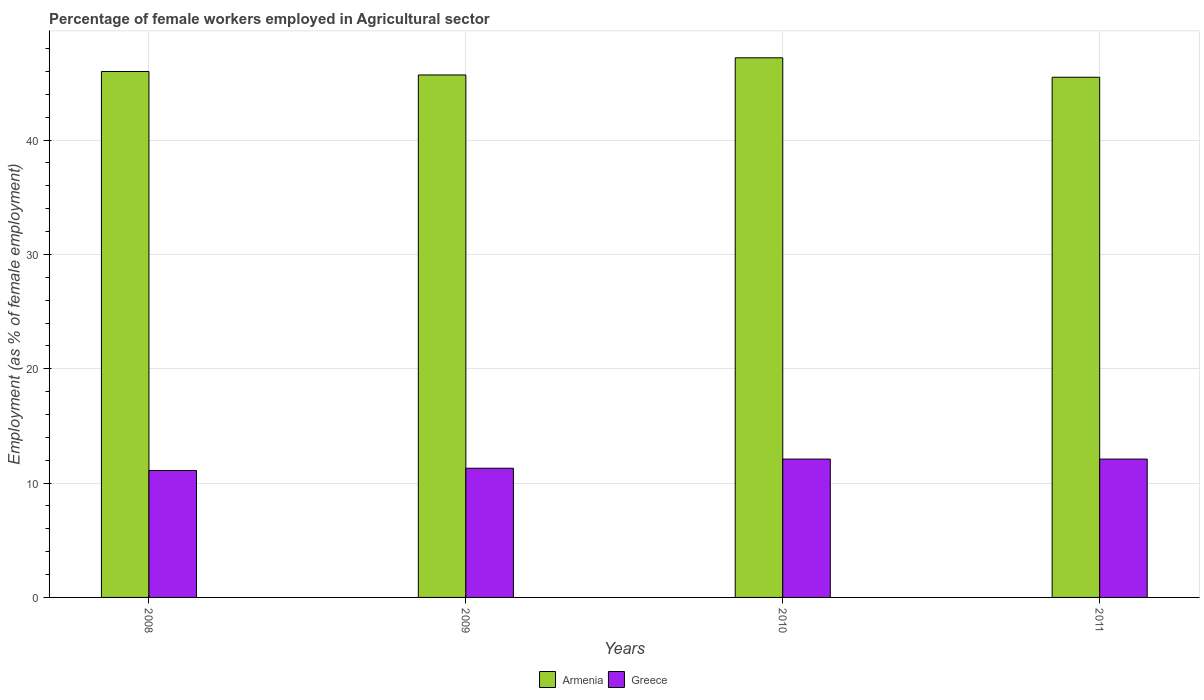How many different coloured bars are there?
Ensure brevity in your answer.  2. Are the number of bars per tick equal to the number of legend labels?
Give a very brief answer. Yes. In how many cases, is the number of bars for a given year not equal to the number of legend labels?
Make the answer very short. 0. What is the percentage of females employed in Agricultural sector in Greece in 2009?
Give a very brief answer. 11.3. Across all years, what is the maximum percentage of females employed in Agricultural sector in Armenia?
Give a very brief answer. 47.2. Across all years, what is the minimum percentage of females employed in Agricultural sector in Greece?
Offer a very short reply. 11.1. What is the total percentage of females employed in Agricultural sector in Armenia in the graph?
Your answer should be very brief. 184.4. What is the difference between the percentage of females employed in Agricultural sector in Armenia in 2008 and that in 2009?
Offer a terse response. 0.3. What is the difference between the percentage of females employed in Agricultural sector in Armenia in 2010 and the percentage of females employed in Agricultural sector in Greece in 2009?
Keep it short and to the point. 35.9. What is the average percentage of females employed in Agricultural sector in Greece per year?
Your answer should be very brief. 11.65. In the year 2010, what is the difference between the percentage of females employed in Agricultural sector in Armenia and percentage of females employed in Agricultural sector in Greece?
Make the answer very short. 35.1. What is the ratio of the percentage of females employed in Agricultural sector in Greece in 2008 to that in 2010?
Provide a short and direct response. 0.92. Is the difference between the percentage of females employed in Agricultural sector in Armenia in 2010 and 2011 greater than the difference between the percentage of females employed in Agricultural sector in Greece in 2010 and 2011?
Your answer should be very brief. Yes. What is the difference between the highest and the second highest percentage of females employed in Agricultural sector in Greece?
Your answer should be very brief. 0. What is the difference between the highest and the lowest percentage of females employed in Agricultural sector in Greece?
Your answer should be very brief. 1. What does the 2nd bar from the left in 2011 represents?
Offer a very short reply. Greece. How many years are there in the graph?
Make the answer very short. 4. What is the difference between two consecutive major ticks on the Y-axis?
Your response must be concise. 10. Are the values on the major ticks of Y-axis written in scientific E-notation?
Offer a very short reply. No. Does the graph contain grids?
Keep it short and to the point. Yes. How are the legend labels stacked?
Offer a very short reply. Horizontal. What is the title of the graph?
Make the answer very short. Percentage of female workers employed in Agricultural sector. Does "Mali" appear as one of the legend labels in the graph?
Offer a terse response. No. What is the label or title of the Y-axis?
Provide a short and direct response. Employment (as % of female employment). What is the Employment (as % of female employment) of Armenia in 2008?
Provide a short and direct response. 46. What is the Employment (as % of female employment) in Greece in 2008?
Offer a very short reply. 11.1. What is the Employment (as % of female employment) in Armenia in 2009?
Keep it short and to the point. 45.7. What is the Employment (as % of female employment) in Greece in 2009?
Your answer should be compact. 11.3. What is the Employment (as % of female employment) of Armenia in 2010?
Ensure brevity in your answer.  47.2. What is the Employment (as % of female employment) in Greece in 2010?
Give a very brief answer. 12.1. What is the Employment (as % of female employment) in Armenia in 2011?
Make the answer very short. 45.5. What is the Employment (as % of female employment) in Greece in 2011?
Keep it short and to the point. 12.1. Across all years, what is the maximum Employment (as % of female employment) of Armenia?
Provide a short and direct response. 47.2. Across all years, what is the maximum Employment (as % of female employment) of Greece?
Ensure brevity in your answer.  12.1. Across all years, what is the minimum Employment (as % of female employment) in Armenia?
Your answer should be compact. 45.5. Across all years, what is the minimum Employment (as % of female employment) of Greece?
Make the answer very short. 11.1. What is the total Employment (as % of female employment) in Armenia in the graph?
Provide a short and direct response. 184.4. What is the total Employment (as % of female employment) in Greece in the graph?
Your answer should be compact. 46.6. What is the difference between the Employment (as % of female employment) of Armenia in 2008 and that in 2009?
Ensure brevity in your answer.  0.3. What is the difference between the Employment (as % of female employment) of Greece in 2008 and that in 2010?
Offer a terse response. -1. What is the difference between the Employment (as % of female employment) in Armenia in 2008 and that in 2011?
Give a very brief answer. 0.5. What is the difference between the Employment (as % of female employment) of Greece in 2008 and that in 2011?
Ensure brevity in your answer.  -1. What is the difference between the Employment (as % of female employment) of Greece in 2009 and that in 2011?
Ensure brevity in your answer.  -0.8. What is the difference between the Employment (as % of female employment) of Armenia in 2008 and the Employment (as % of female employment) of Greece in 2009?
Offer a terse response. 34.7. What is the difference between the Employment (as % of female employment) in Armenia in 2008 and the Employment (as % of female employment) in Greece in 2010?
Your response must be concise. 33.9. What is the difference between the Employment (as % of female employment) in Armenia in 2008 and the Employment (as % of female employment) in Greece in 2011?
Ensure brevity in your answer.  33.9. What is the difference between the Employment (as % of female employment) of Armenia in 2009 and the Employment (as % of female employment) of Greece in 2010?
Offer a very short reply. 33.6. What is the difference between the Employment (as % of female employment) of Armenia in 2009 and the Employment (as % of female employment) of Greece in 2011?
Make the answer very short. 33.6. What is the difference between the Employment (as % of female employment) of Armenia in 2010 and the Employment (as % of female employment) of Greece in 2011?
Offer a terse response. 35.1. What is the average Employment (as % of female employment) of Armenia per year?
Give a very brief answer. 46.1. What is the average Employment (as % of female employment) in Greece per year?
Ensure brevity in your answer.  11.65. In the year 2008, what is the difference between the Employment (as % of female employment) of Armenia and Employment (as % of female employment) of Greece?
Your response must be concise. 34.9. In the year 2009, what is the difference between the Employment (as % of female employment) of Armenia and Employment (as % of female employment) of Greece?
Offer a very short reply. 34.4. In the year 2010, what is the difference between the Employment (as % of female employment) of Armenia and Employment (as % of female employment) of Greece?
Keep it short and to the point. 35.1. In the year 2011, what is the difference between the Employment (as % of female employment) in Armenia and Employment (as % of female employment) in Greece?
Your answer should be very brief. 33.4. What is the ratio of the Employment (as % of female employment) in Armenia in 2008 to that in 2009?
Provide a succinct answer. 1.01. What is the ratio of the Employment (as % of female employment) of Greece in 2008 to that in 2009?
Your answer should be very brief. 0.98. What is the ratio of the Employment (as % of female employment) of Armenia in 2008 to that in 2010?
Offer a very short reply. 0.97. What is the ratio of the Employment (as % of female employment) of Greece in 2008 to that in 2010?
Provide a short and direct response. 0.92. What is the ratio of the Employment (as % of female employment) in Greece in 2008 to that in 2011?
Keep it short and to the point. 0.92. What is the ratio of the Employment (as % of female employment) of Armenia in 2009 to that in 2010?
Offer a very short reply. 0.97. What is the ratio of the Employment (as % of female employment) in Greece in 2009 to that in 2010?
Offer a terse response. 0.93. What is the ratio of the Employment (as % of female employment) in Greece in 2009 to that in 2011?
Ensure brevity in your answer.  0.93. What is the ratio of the Employment (as % of female employment) of Armenia in 2010 to that in 2011?
Your answer should be compact. 1.04. What is the ratio of the Employment (as % of female employment) of Greece in 2010 to that in 2011?
Provide a short and direct response. 1. What is the difference between the highest and the second highest Employment (as % of female employment) of Armenia?
Offer a very short reply. 1.2. 